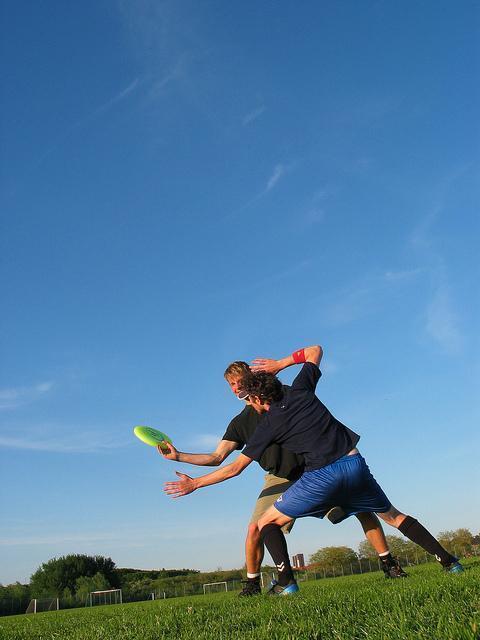How many people can be seen?
Give a very brief answer. 2. 